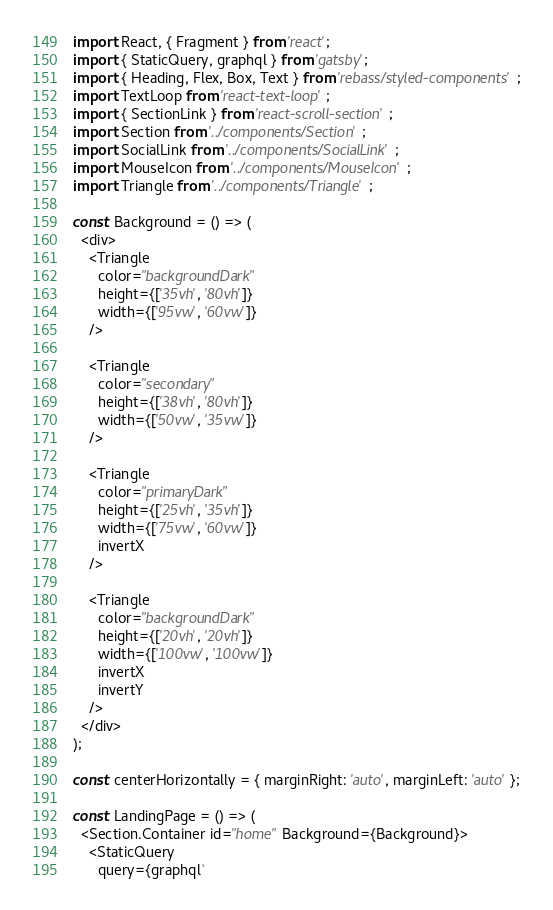Convert code to text. <code><loc_0><loc_0><loc_500><loc_500><_JavaScript_>import React, { Fragment } from 'react';
import { StaticQuery, graphql } from 'gatsby';
import { Heading, Flex, Box, Text } from 'rebass/styled-components';
import TextLoop from 'react-text-loop';
import { SectionLink } from 'react-scroll-section';
import Section from '../components/Section';
import SocialLink from '../components/SocialLink';
import MouseIcon from '../components/MouseIcon';
import Triangle from '../components/Triangle';

const Background = () => (
  <div>
    <Triangle
      color="backgroundDark"
      height={['35vh', '80vh']}
      width={['95vw', '60vw']}
    />

    <Triangle
      color="secondary"
      height={['38vh', '80vh']}
      width={['50vw', '35vw']}
    />

    <Triangle
      color="primaryDark"
      height={['25vh', '35vh']}
      width={['75vw', '60vw']}
      invertX
    />

    <Triangle
      color="backgroundDark"
      height={['20vh', '20vh']}
      width={['100vw', '100vw']}
      invertX
      invertY
    />
  </div>
);

const centerHorizontally = { marginRight: 'auto', marginLeft: 'auto' };

const LandingPage = () => (
  <Section.Container id="home" Background={Background}>
    <StaticQuery
      query={graphql`</code> 